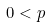<formula> <loc_0><loc_0><loc_500><loc_500>0 < p</formula> 